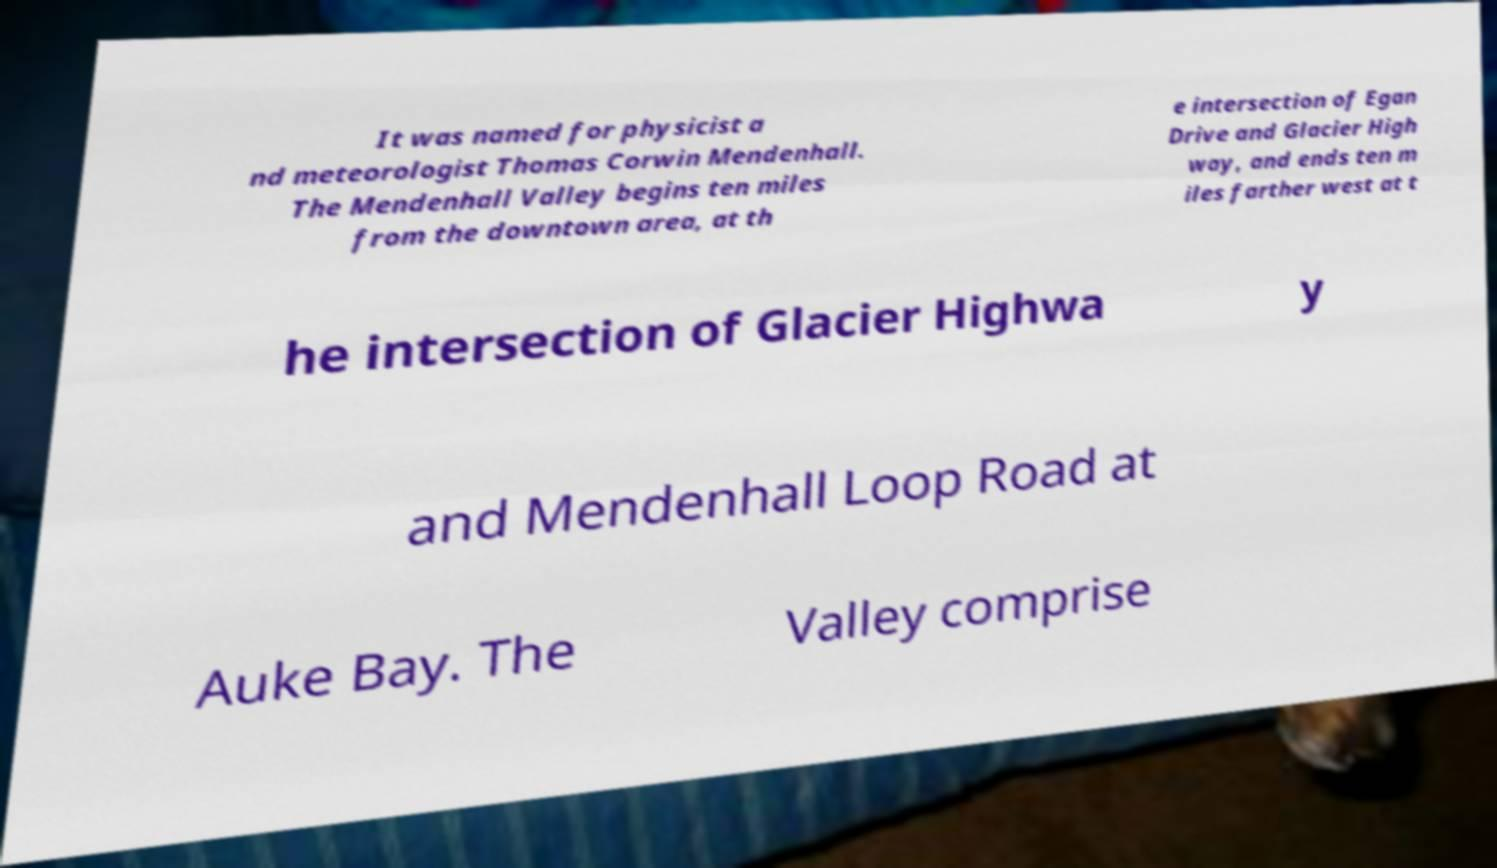Could you extract and type out the text from this image? It was named for physicist a nd meteorologist Thomas Corwin Mendenhall. The Mendenhall Valley begins ten miles from the downtown area, at th e intersection of Egan Drive and Glacier High way, and ends ten m iles farther west at t he intersection of Glacier Highwa y and Mendenhall Loop Road at Auke Bay. The Valley comprise 